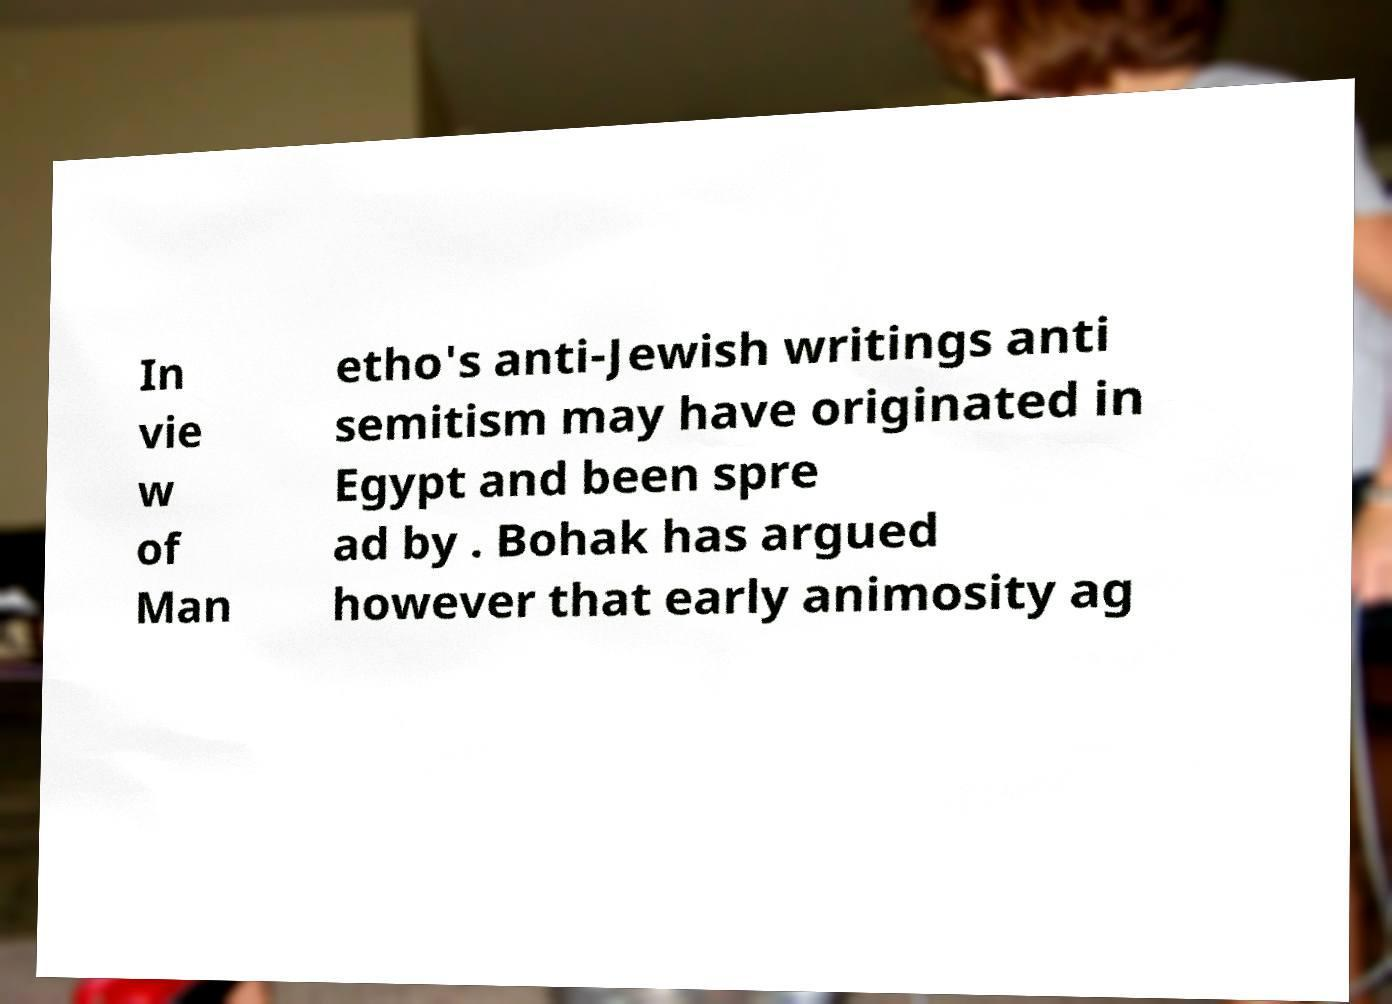Can you accurately transcribe the text from the provided image for me? In vie w of Man etho's anti-Jewish writings anti semitism may have originated in Egypt and been spre ad by . Bohak has argued however that early animosity ag 